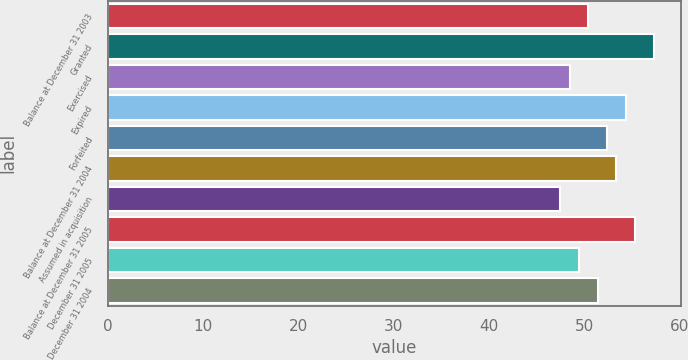Convert chart. <chart><loc_0><loc_0><loc_500><loc_500><bar_chart><fcel>Balance at December 31 2003<fcel>Granted<fcel>Exercised<fcel>Expired<fcel>Forfeited<fcel>Balance at December 31 2004<fcel>Assumed in acquisition<fcel>Balance at December 31 2005<fcel>December 31 2005<fcel>December 31 2004<nl><fcel>50.38<fcel>57.28<fcel>48.42<fcel>54.3<fcel>52.34<fcel>53.32<fcel>47.44<fcel>55.28<fcel>49.4<fcel>51.36<nl></chart> 